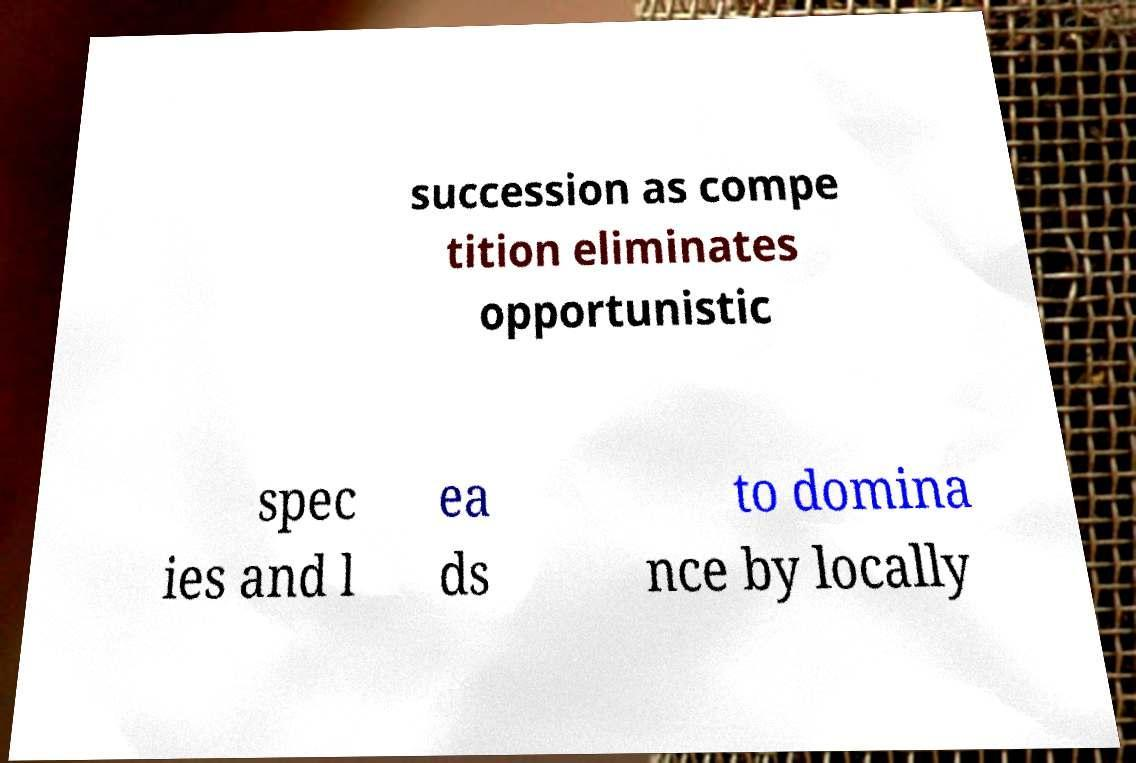Can you accurately transcribe the text from the provided image for me? succession as compe tition eliminates opportunistic spec ies and l ea ds to domina nce by locally 